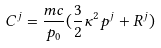<formula> <loc_0><loc_0><loc_500><loc_500>C ^ { j } = \frac { m c } { p _ { 0 } } ( \frac { 3 } { 2 } \kappa ^ { 2 } p ^ { j } + R ^ { j } )</formula> 